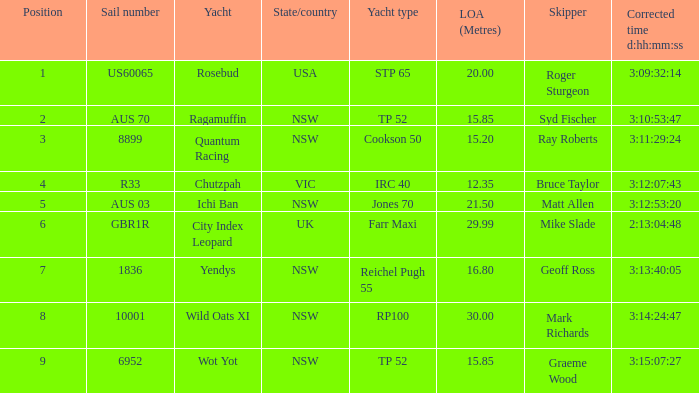What were all sailboats having a sail number of 6952? Wot Yot. 